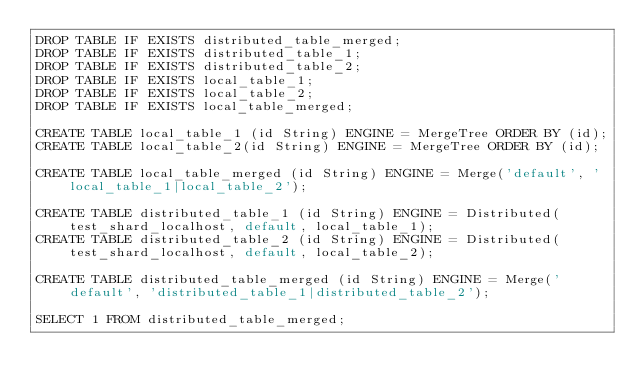Convert code to text. <code><loc_0><loc_0><loc_500><loc_500><_SQL_>DROP TABLE IF EXISTS distributed_table_merged;
DROP TABLE IF EXISTS distributed_table_1;
DROP TABLE IF EXISTS distributed_table_2;
DROP TABLE IF EXISTS local_table_1;
DROP TABLE IF EXISTS local_table_2;
DROP TABLE IF EXISTS local_table_merged;

CREATE TABLE local_table_1 (id String) ENGINE = MergeTree ORDER BY (id);
CREATE TABLE local_table_2(id String) ENGINE = MergeTree ORDER BY (id);

CREATE TABLE local_table_merged (id String) ENGINE = Merge('default', 'local_table_1|local_table_2');

CREATE TABLE distributed_table_1 (id String) ENGINE = Distributed(test_shard_localhost, default, local_table_1);
CREATE TABLE distributed_table_2 (id String) ENGINE = Distributed(test_shard_localhost, default, local_table_2);

CREATE TABLE distributed_table_merged (id String) ENGINE = Merge('default', 'distributed_table_1|distributed_table_2');

SELECT 1 FROM distributed_table_merged;
</code> 